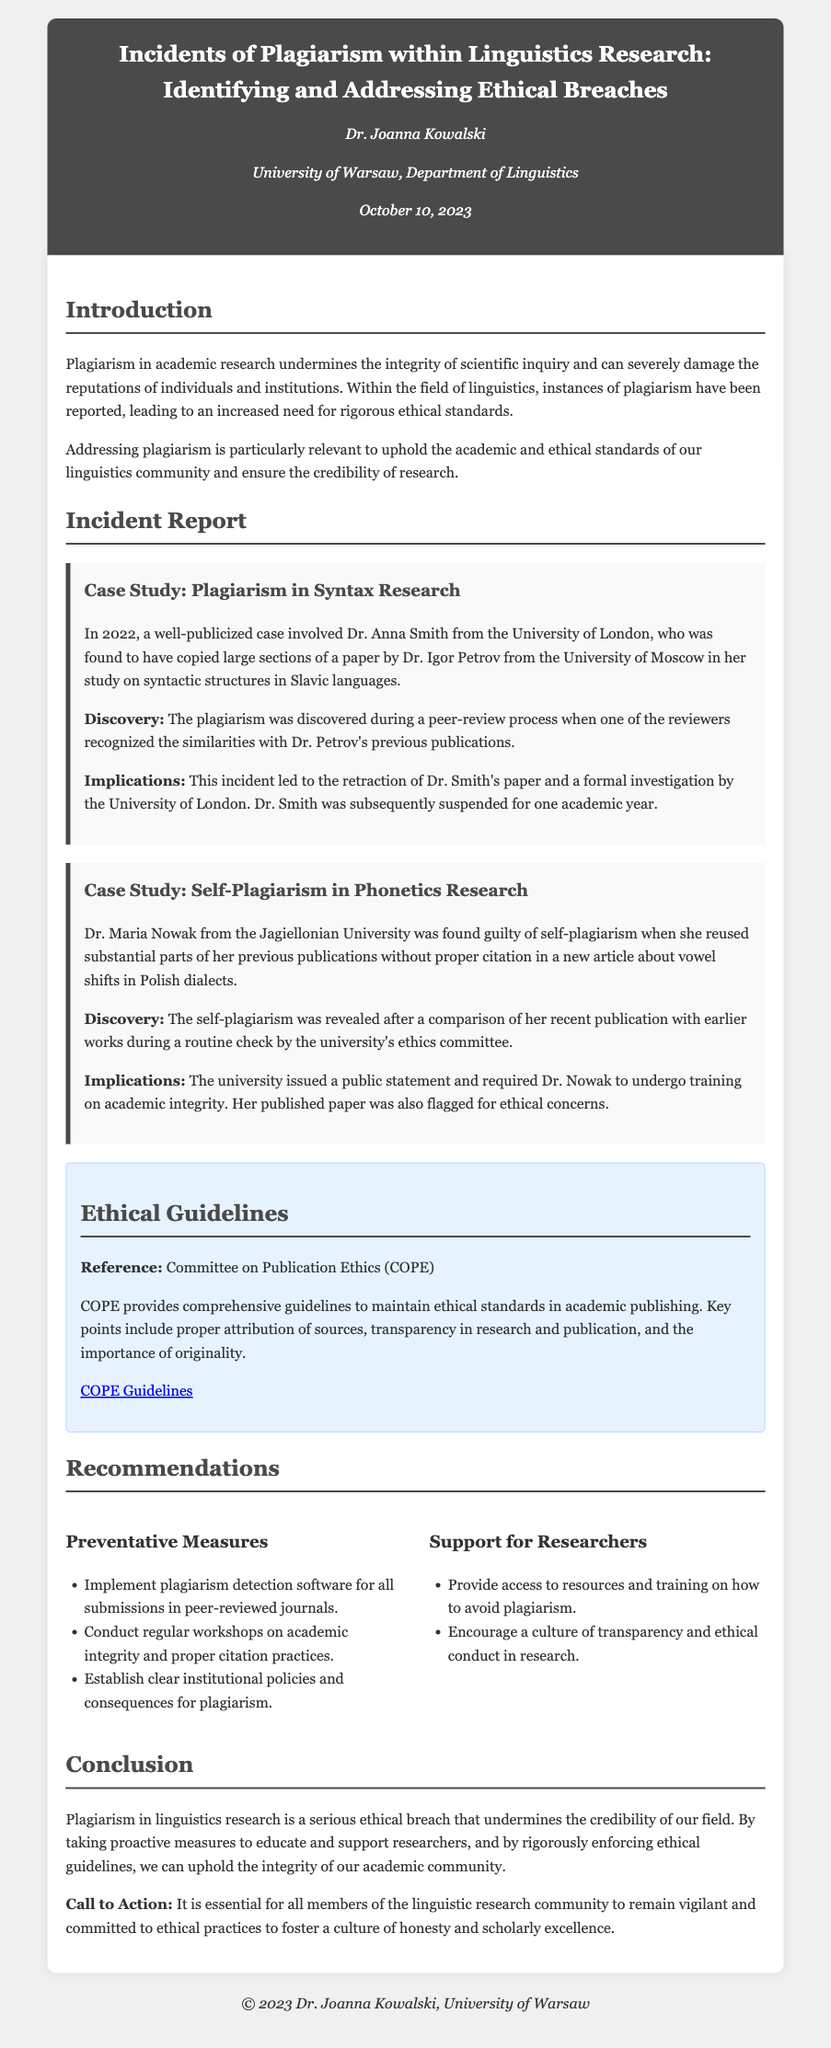What is the title of the report? The title of the report is found in the header section of the document.
Answer: Incidents of Plagiarism within Linguistics Research: Identifying and Addressing Ethical Breaches Who authored the report? The author's information is stated in the header section.
Answer: Dr. Joanna Kowalski When was the report published? The publication date is provided in the author information section.
Answer: October 10, 2023 What university is Dr. Anna Smith associated with? Dr. Anna Smith's affiliation is mentioned in the incident report section.
Answer: University of London What is the consequence faced by Dr. Smith? The implications of the incident regarding Dr. Smith are detailed in the case study.
Answer: Suspended for one academic year What was the main violation committed by Dr. Maria Nowak? The type of plagiarism committed by Dr. Nowak is described in her case study.
Answer: Self-plagiarism What type of software is recommended for journal submissions? Preventative measures section outlines recommended tools for ensuring ethical practices.
Answer: Plagiarism detection software What is a resource mentioned for ethical guidelines? The ethical guidelines section mentions a specific resource for maintaining standards.
Answer: Committee on Publication Ethics (COPE) What consequences were required for Dr. Nowak? The implications for Dr. Nowak's actions are summarized in her case study.
Answer: Required to undergo training on academic integrity What is the call to action in the conclusion? The conclusion emphasizes the importance of ethical practices in academic conduct.
Answer: Remain vigilant and committed to ethical practices 